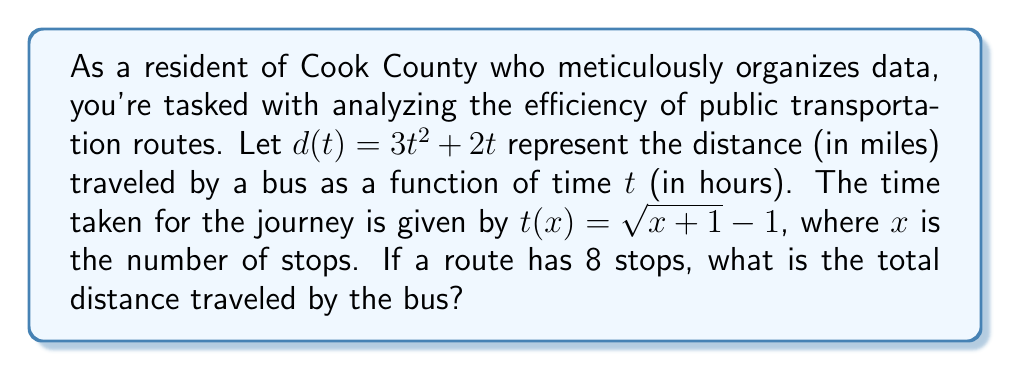Provide a solution to this math problem. Let's approach this step-by-step:

1) We're given two functions:
   $d(t) = 3t^2 + 2t$ (distance as a function of time)
   $t(x) = \sqrt{x+1} - 1$ (time as a function of number of stops)

2) We need to find the composite function $d(t(x))$ to get the distance as a function of the number of stops.

3) First, let's substitute $t(x)$ into $d(t)$:
   $d(t(x)) = 3(\sqrt{x+1} - 1)^2 + 2(\sqrt{x+1} - 1)$

4) Let's expand this:
   $d(t(x)) = 3(x+1 - 2\sqrt{x+1} + 1) + 2\sqrt{x+1} - 2$
   $d(t(x)) = 3x + 3 - 6\sqrt{x+1} + 3 + 2\sqrt{x+1} - 2$
   $d(t(x)) = 3x + 4 - 4\sqrt{x+1}$

5) Now we have the distance as a function of the number of stops.

6) The question asks for the distance when there are 8 stops. So let's substitute $x = 8$:
   $d(t(8)) = 3(8) + 4 - 4\sqrt{8+1}$
   $d(t(8)) = 24 + 4 - 4\sqrt{9}$
   $d(t(8)) = 28 - 4(3)$
   $d(t(8)) = 28 - 12 = 16$

Therefore, the total distance traveled by the bus is 16 miles.
Answer: 16 miles 